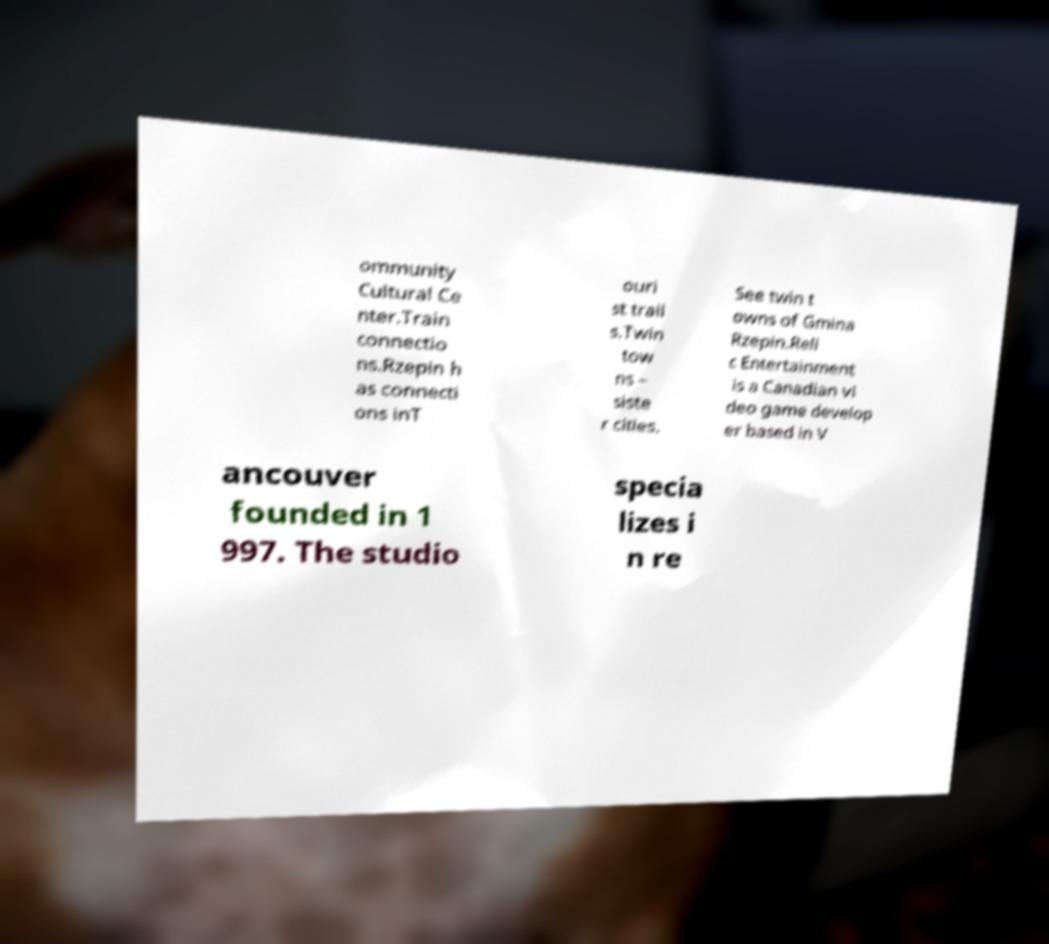Could you assist in decoding the text presented in this image and type it out clearly? ommunity Cultural Ce nter.Train connectio ns.Rzepin h as connecti ons inT ouri st trail s.Twin tow ns – siste r cities. See twin t owns of Gmina Rzepin.Reli c Entertainment is a Canadian vi deo game develop er based in V ancouver founded in 1 997. The studio specia lizes i n re 